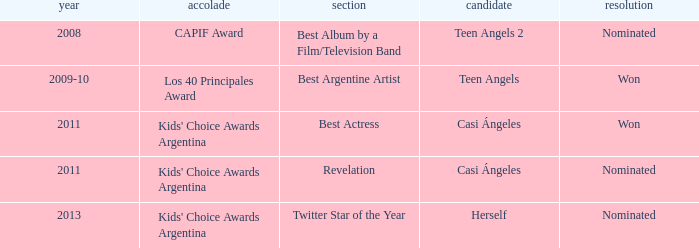For which accolade was a best actress nomination received? Kids' Choice Awards Argentina. Parse the table in full. {'header': ['year', 'accolade', 'section', 'candidate', 'resolution'], 'rows': [['2008', 'CAPIF Award', 'Best Album by a Film/Television Band', 'Teen Angels 2', 'Nominated'], ['2009-10', 'Los 40 Principales Award', 'Best Argentine Artist', 'Teen Angels', 'Won'], ['2011', "Kids' Choice Awards Argentina", 'Best Actress', 'Casi Ángeles', 'Won'], ['2011', "Kids' Choice Awards Argentina", 'Revelation', 'Casi Ángeles', 'Nominated'], ['2013', "Kids' Choice Awards Argentina", 'Twitter Star of the Year', 'Herself', 'Nominated']]} 